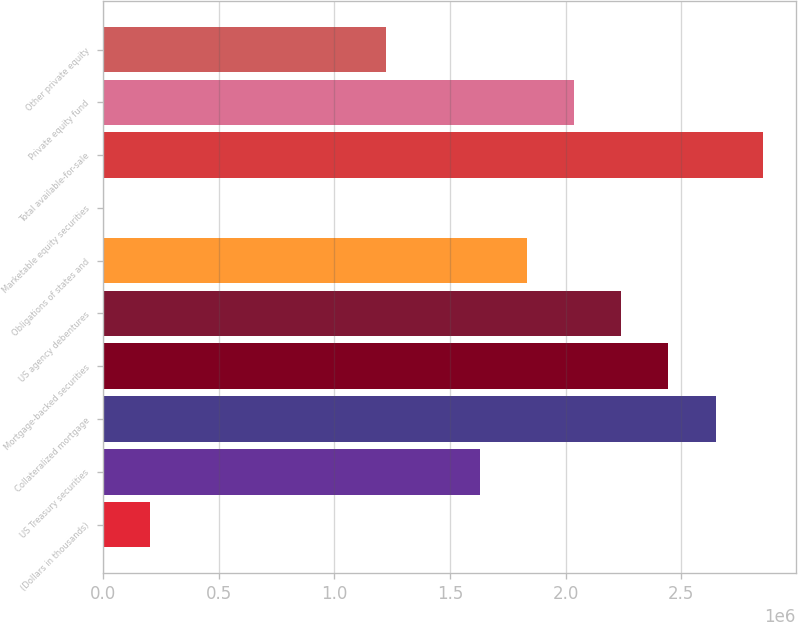<chart> <loc_0><loc_0><loc_500><loc_500><bar_chart><fcel>(Dollars in thousands)<fcel>US Treasury securities<fcel>Collateralized mortgage<fcel>Mortgage-backed securities<fcel>US agency debentures<fcel>Obligations of states and<fcel>Marketable equity securities<fcel>Total available-for-sale<fcel>Private equity fund<fcel>Other private equity<nl><fcel>204297<fcel>1.62994e+06<fcel>2.64826e+06<fcel>2.4446e+06<fcel>2.24093e+06<fcel>1.83361e+06<fcel>633<fcel>2.85192e+06<fcel>2.03727e+06<fcel>1.22262e+06<nl></chart> 